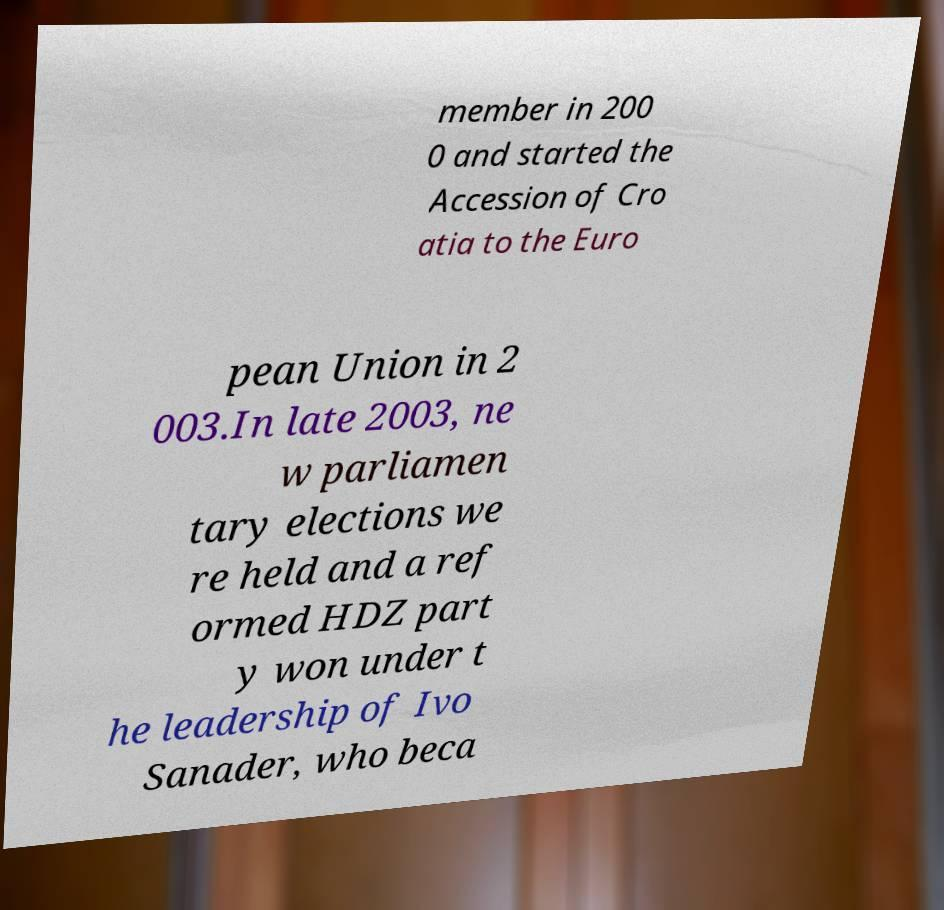Could you extract and type out the text from this image? member in 200 0 and started the Accession of Cro atia to the Euro pean Union in 2 003.In late 2003, ne w parliamen tary elections we re held and a ref ormed HDZ part y won under t he leadership of Ivo Sanader, who beca 